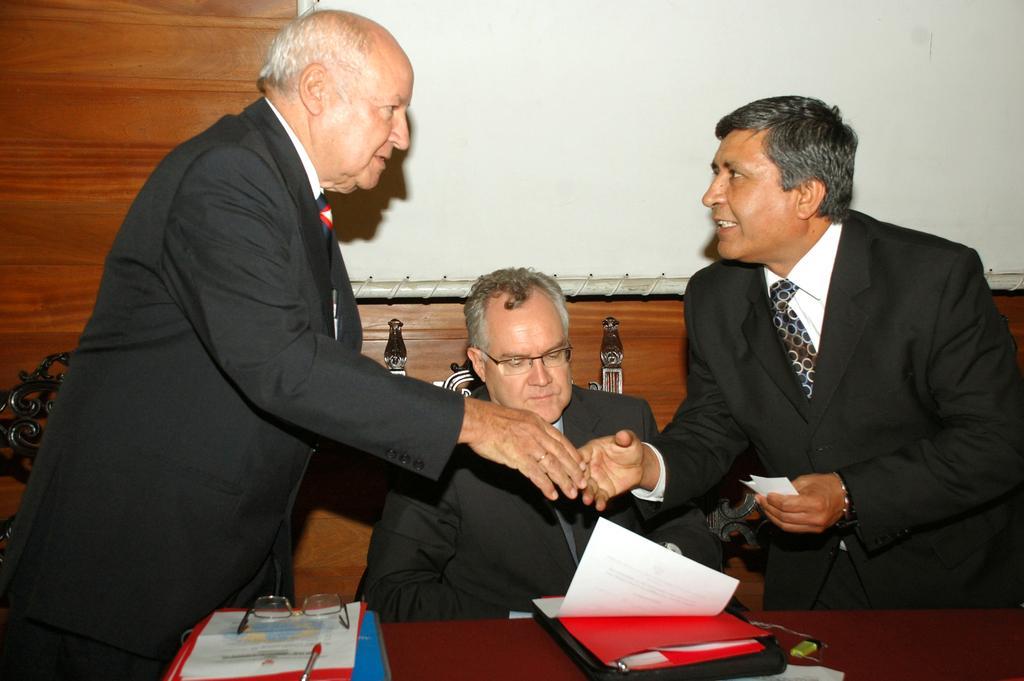Can you describe this image briefly? In the center of this picture there is a person wearing suit and sitting on the chair and we can see the two persons wearing suits and standing and seems to be shaking their hands and we can see a table on the top of which books and some other objects are placed. In the background we can see the wall and a projector screen. 